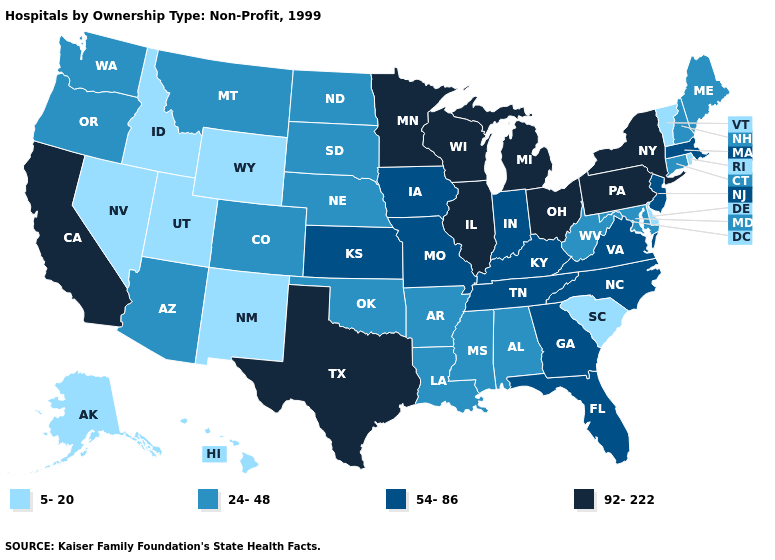What is the value of Tennessee?
Write a very short answer. 54-86. Which states have the highest value in the USA?
Short answer required. California, Illinois, Michigan, Minnesota, New York, Ohio, Pennsylvania, Texas, Wisconsin. What is the value of Rhode Island?
Answer briefly. 5-20. Which states hav the highest value in the MidWest?
Be succinct. Illinois, Michigan, Minnesota, Ohio, Wisconsin. Does the first symbol in the legend represent the smallest category?
Short answer required. Yes. What is the value of Wisconsin?
Be succinct. 92-222. Name the states that have a value in the range 24-48?
Quick response, please. Alabama, Arizona, Arkansas, Colorado, Connecticut, Louisiana, Maine, Maryland, Mississippi, Montana, Nebraska, New Hampshire, North Dakota, Oklahoma, Oregon, South Dakota, Washington, West Virginia. Name the states that have a value in the range 54-86?
Write a very short answer. Florida, Georgia, Indiana, Iowa, Kansas, Kentucky, Massachusetts, Missouri, New Jersey, North Carolina, Tennessee, Virginia. Does Virginia have a higher value than Tennessee?
Give a very brief answer. No. Name the states that have a value in the range 92-222?
Quick response, please. California, Illinois, Michigan, Minnesota, New York, Ohio, Pennsylvania, Texas, Wisconsin. How many symbols are there in the legend?
Short answer required. 4. What is the highest value in the USA?
Quick response, please. 92-222. Among the states that border Missouri , which have the highest value?
Quick response, please. Illinois. What is the value of Delaware?
Be succinct. 5-20. Which states have the lowest value in the USA?
Give a very brief answer. Alaska, Delaware, Hawaii, Idaho, Nevada, New Mexico, Rhode Island, South Carolina, Utah, Vermont, Wyoming. 